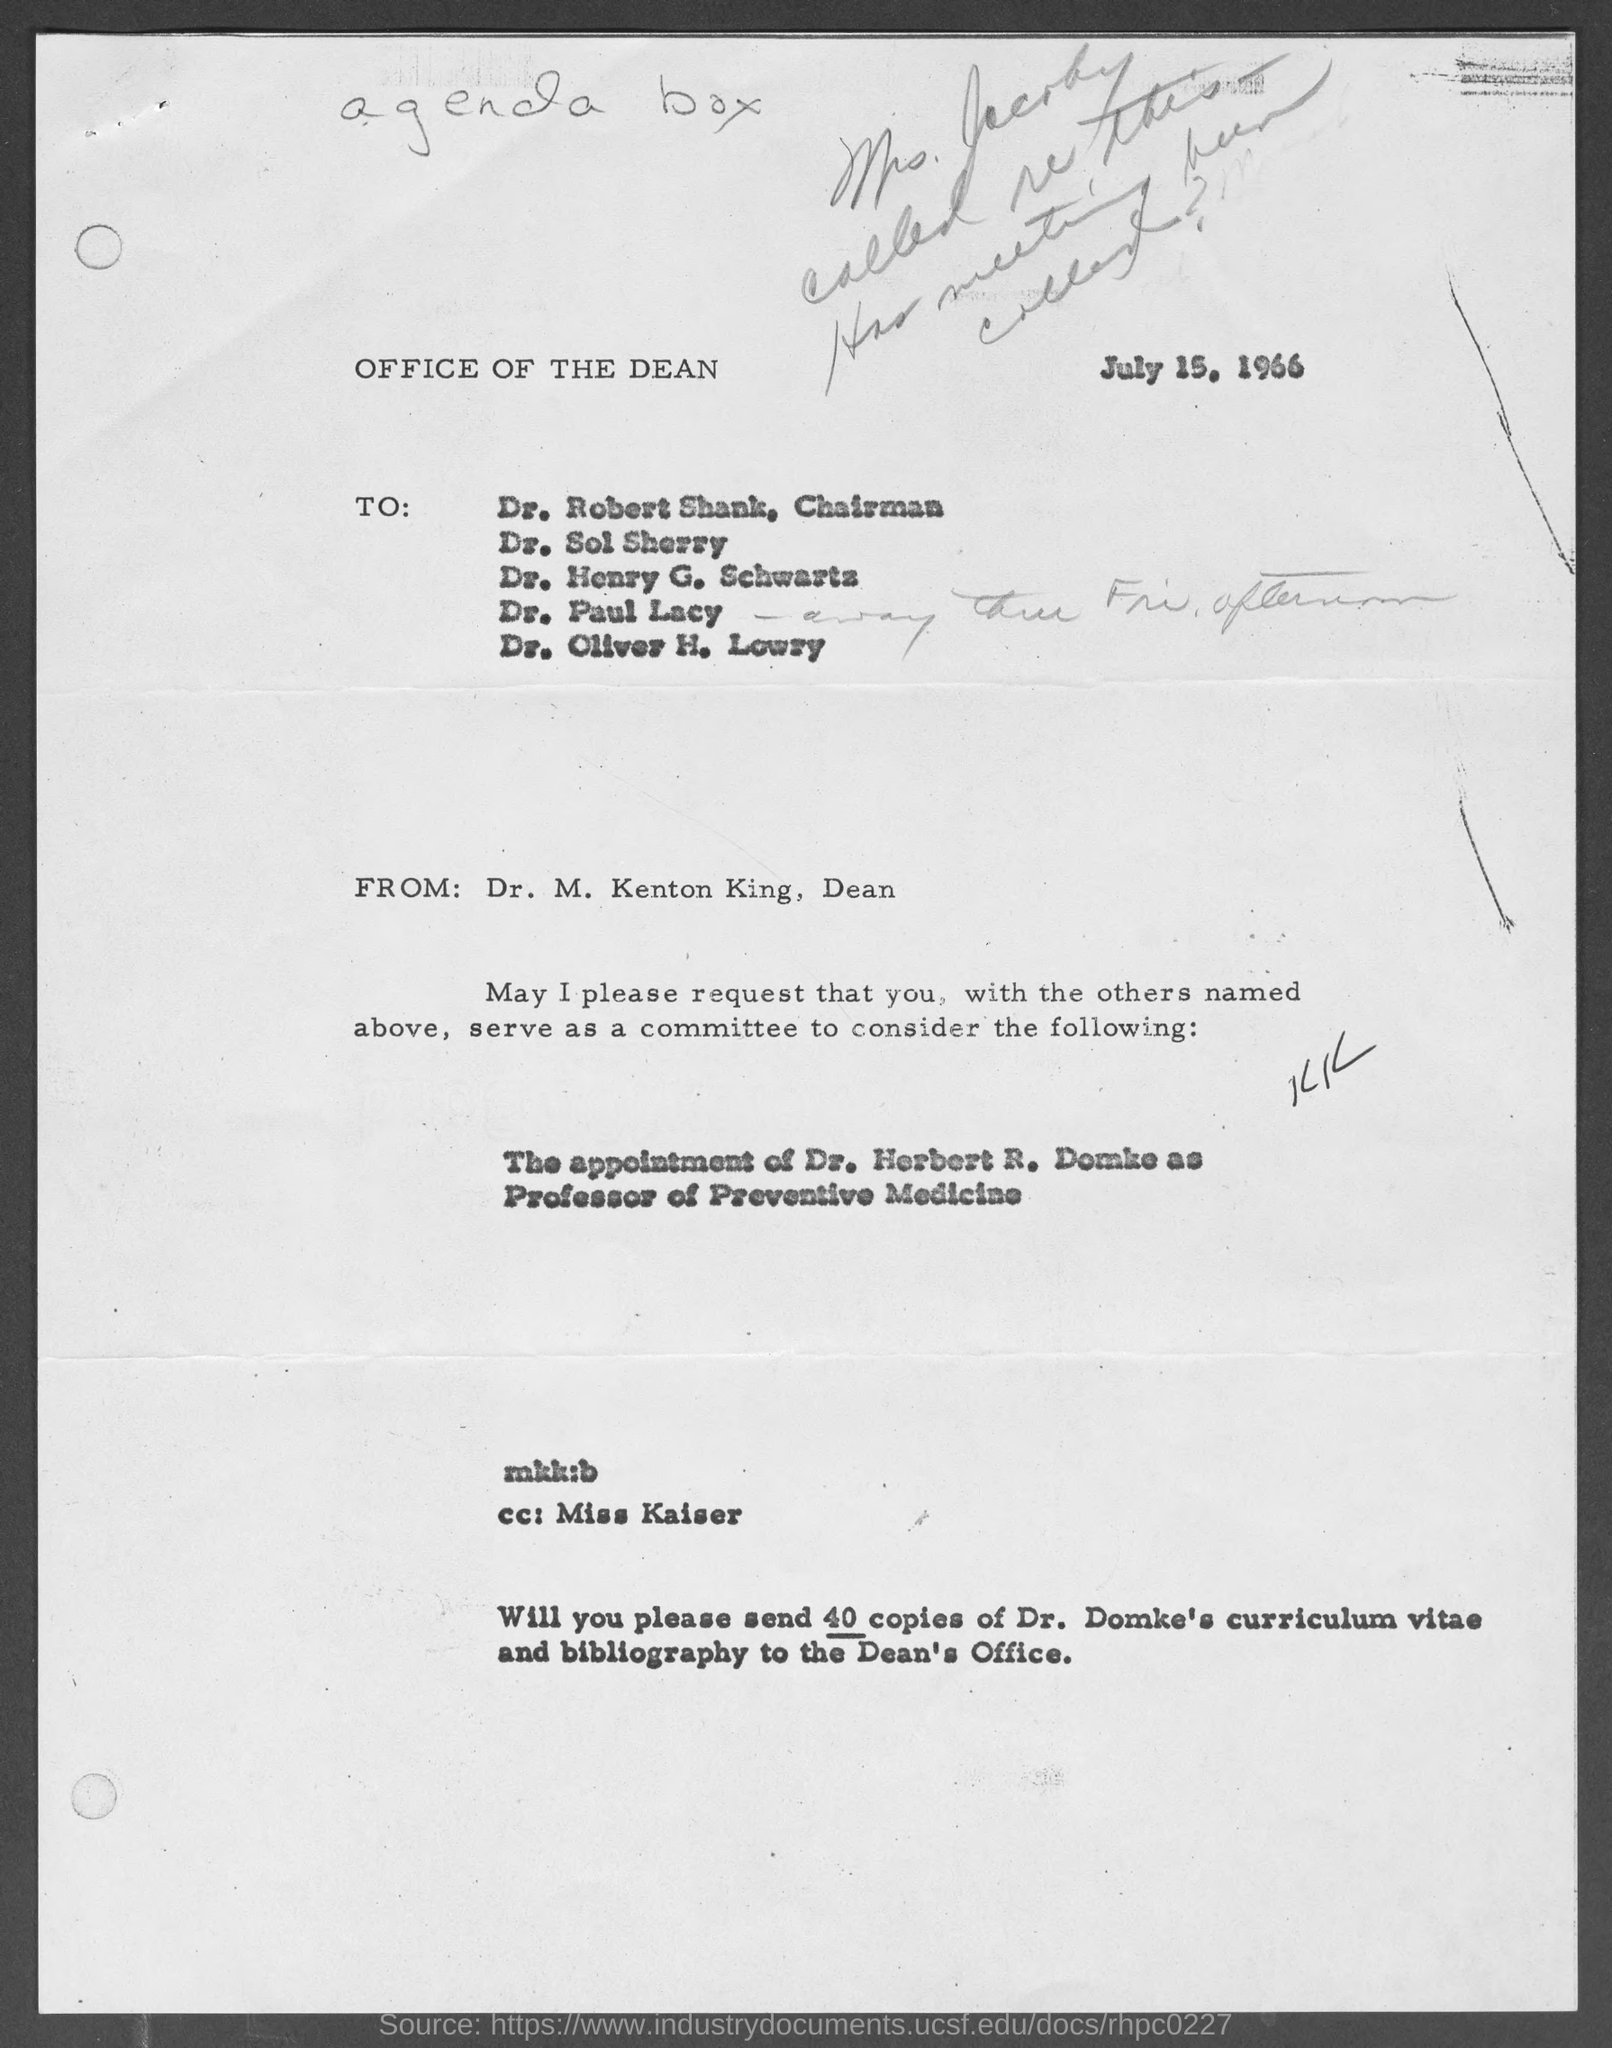When is the letter dated ?
Make the answer very short. July 15, 1966. What is the position of dr. m. kenton king ?
Provide a short and direct response. Dean. What is the position of dr. robert shank?
Ensure brevity in your answer.  Chairman. 